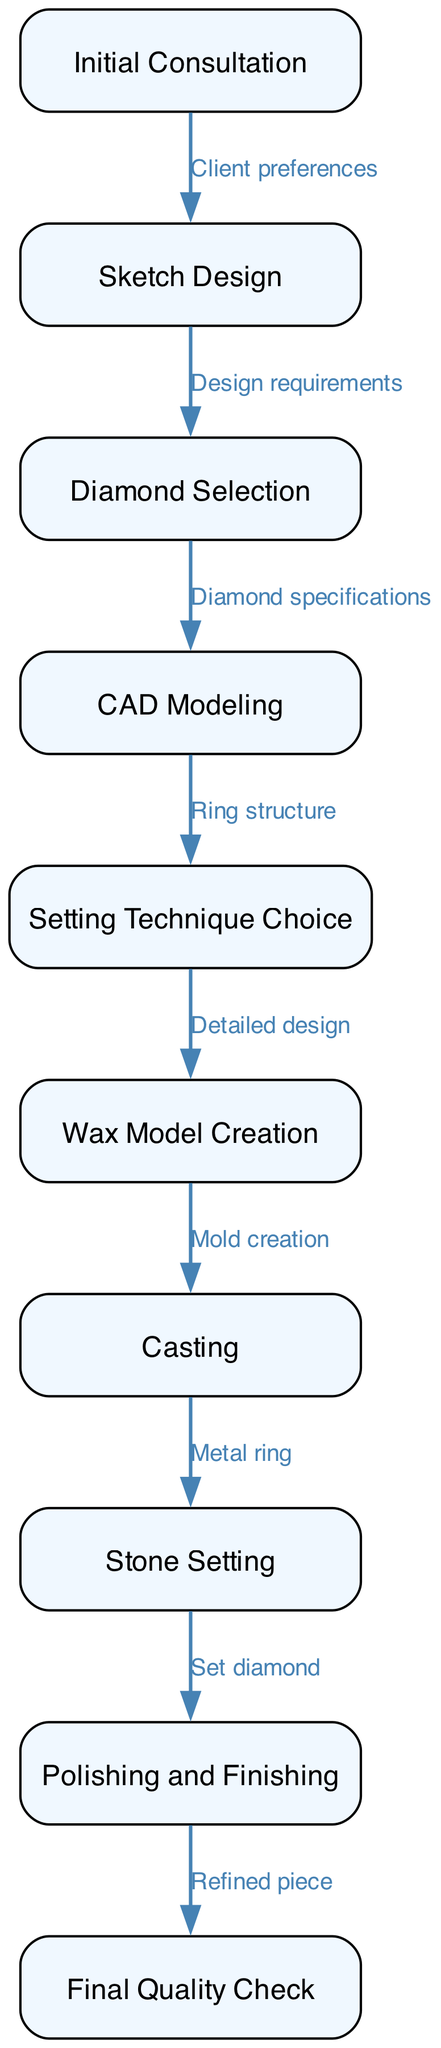What is the first step in the design process? The first step is the "Initial Consultation," where client preferences are gathered.
Answer: Initial Consultation How many nodes are present in the diagram? The diagram contains a total of 10 nodes, each representing a distinct stage in the design process.
Answer: 10 What is the relationship between "Sketch Design" and "Diamond Selection"? The relationship is defined by "Design requirements," indicating that the sketch informs the selection of the diamond.
Answer: Design requirements Which step comes immediately after "Wax Model Creation"? The step that follows "Wax Model Creation" is "Casting," where the mold is used to create the metal ring.
Answer: Casting What is the last step in the process? The final step is "Final Quality Check," which ensures that the refined piece meets all standards before delivery.
Answer: Final Quality Check How many edges connect the nodes in the diagram? There are 9 edges in the diagram, representing the connections between each step in the design process.
Answer: 9 What is the setting technique that follows diamond selection? The setting technique that follows is "Setting Technique Choice," where the appropriate method for the diamond is decided.
Answer: Setting Technique Choice What is required to proceed from "Casting" to "Stone Setting"? To progress from "Casting" to "Stone Setting," the edge "Metal ring" signifies that the ring is ready to have the diamond set.
Answer: Metal ring What does the first edge represent? The first edge represents the transition from "Initial Consultation" to "Sketch Design" based on client preferences gathered during consultation.
Answer: Client preferences 